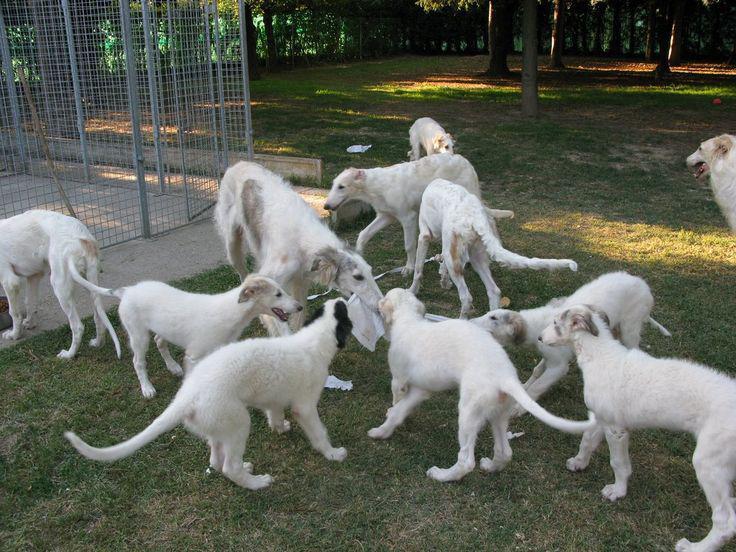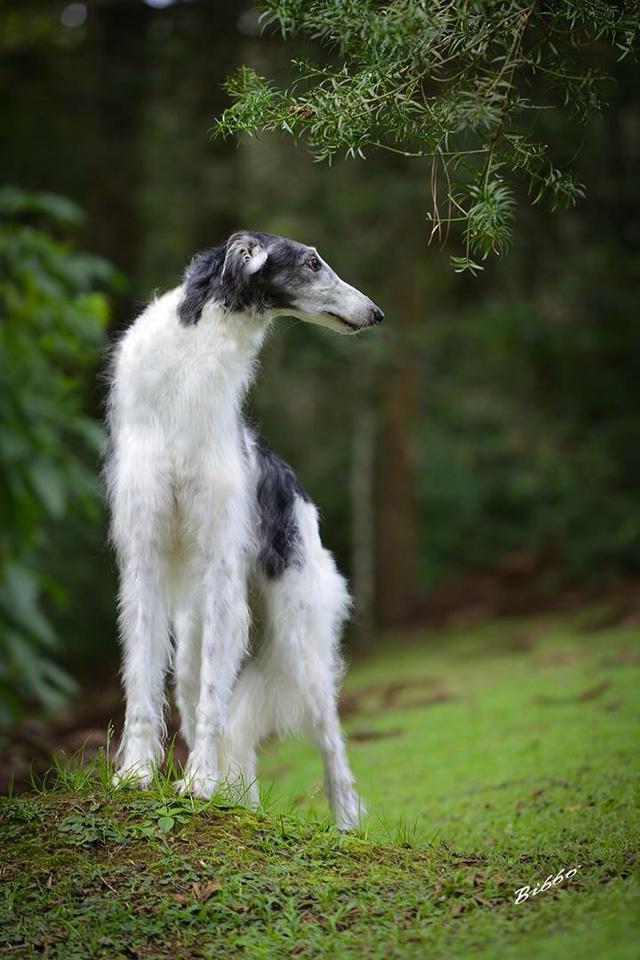The first image is the image on the left, the second image is the image on the right. For the images displayed, is the sentence "Each image shows one hound standing outdoors." factually correct? Answer yes or no. No. The first image is the image on the left, the second image is the image on the right. Examine the images to the left and right. Is the description "There are 2 dogs standing on grass." accurate? Answer yes or no. No. 